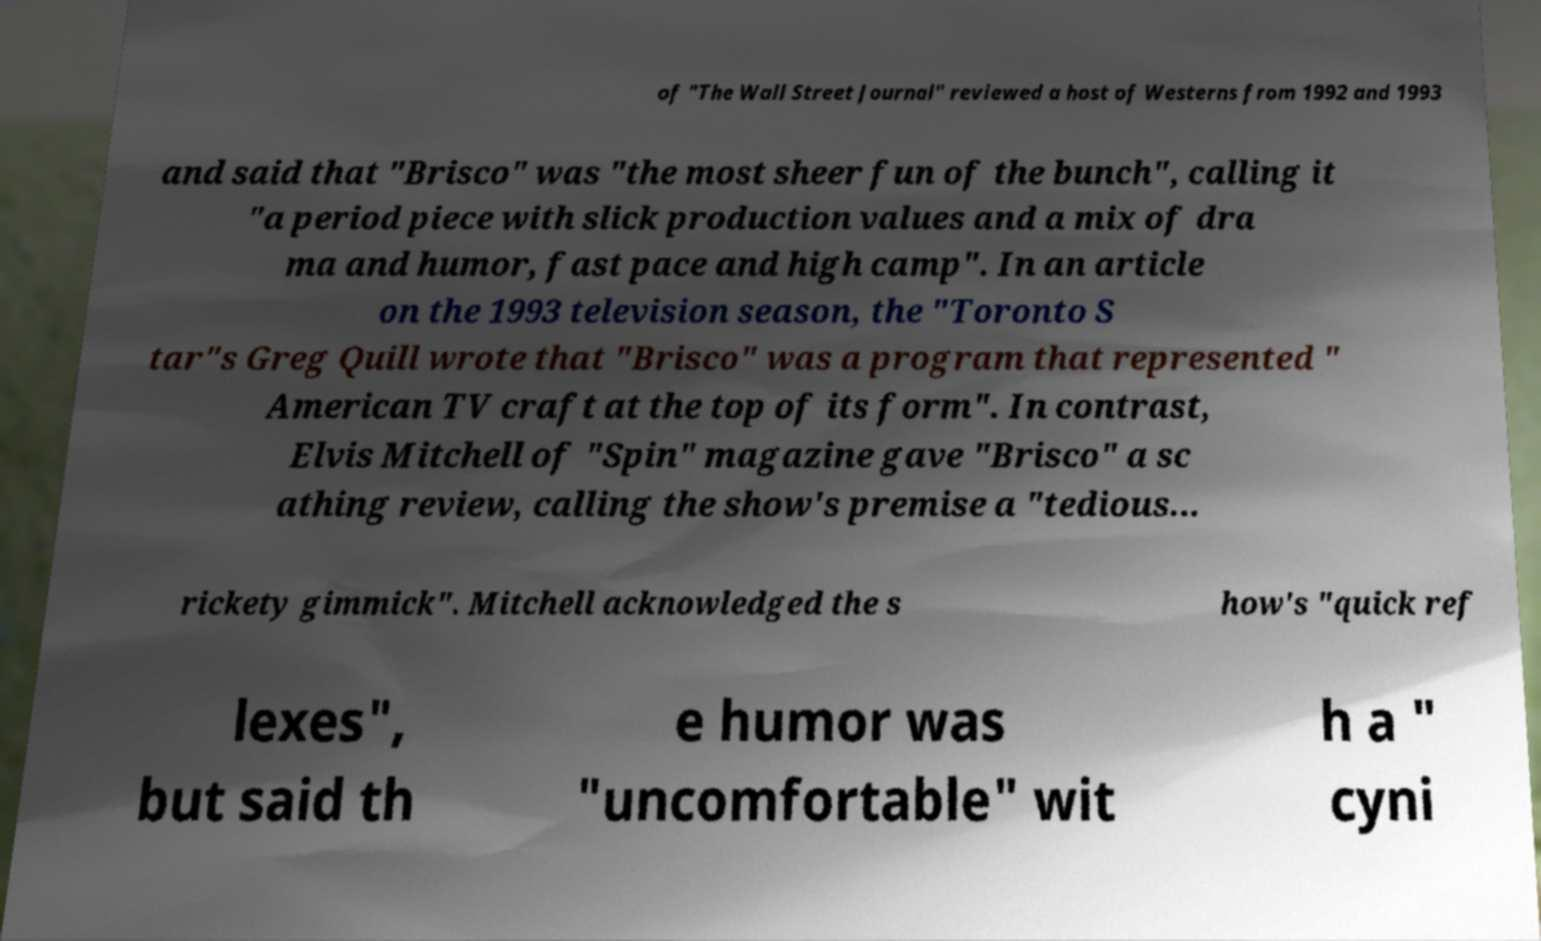Can you accurately transcribe the text from the provided image for me? of "The Wall Street Journal" reviewed a host of Westerns from 1992 and 1993 and said that "Brisco" was "the most sheer fun of the bunch", calling it "a period piece with slick production values and a mix of dra ma and humor, fast pace and high camp". In an article on the 1993 television season, the "Toronto S tar"s Greg Quill wrote that "Brisco" was a program that represented " American TV craft at the top of its form". In contrast, Elvis Mitchell of "Spin" magazine gave "Brisco" a sc athing review, calling the show's premise a "tedious... rickety gimmick". Mitchell acknowledged the s how's "quick ref lexes", but said th e humor was "uncomfortable" wit h a " cyni 